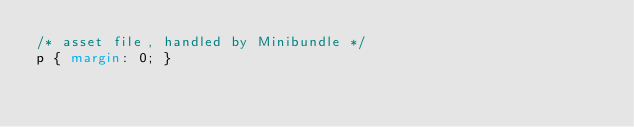Convert code to text. <code><loc_0><loc_0><loc_500><loc_500><_CSS_>/* asset file, handled by Minibundle */
p { margin: 0; }
</code> 